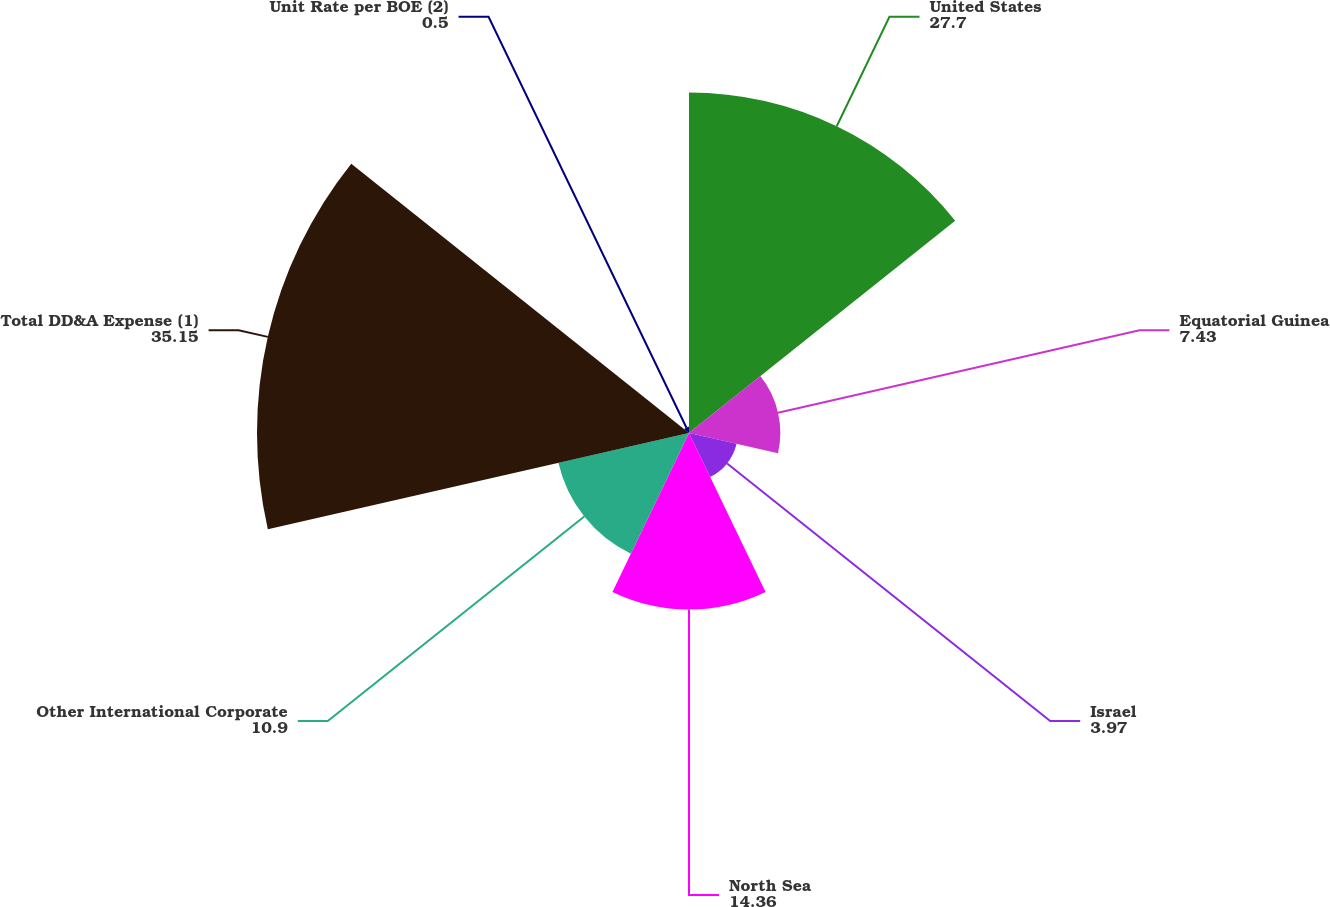Convert chart to OTSL. <chart><loc_0><loc_0><loc_500><loc_500><pie_chart><fcel>United States<fcel>Equatorial Guinea<fcel>Israel<fcel>North Sea<fcel>Other International Corporate<fcel>Total DD&A Expense (1)<fcel>Unit Rate per BOE (2)<nl><fcel>27.7%<fcel>7.43%<fcel>3.97%<fcel>14.36%<fcel>10.9%<fcel>35.15%<fcel>0.5%<nl></chart> 